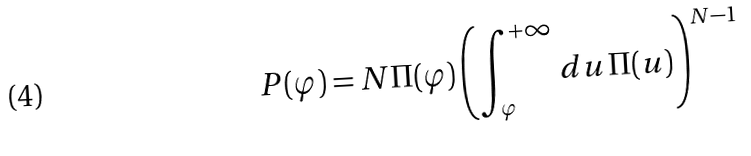Convert formula to latex. <formula><loc_0><loc_0><loc_500><loc_500>P ( \varphi ) = N \Pi ( \varphi ) \left ( \int _ { \varphi } ^ { + \infty } d u \, \Pi ( u ) \right ) ^ { N - 1 }</formula> 